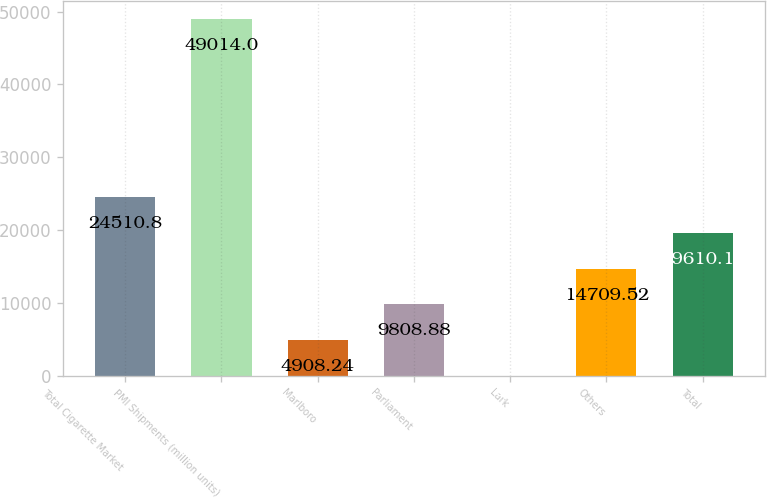<chart> <loc_0><loc_0><loc_500><loc_500><bar_chart><fcel>Total Cigarette Market<fcel>PMI Shipments (million units)<fcel>Marlboro<fcel>Parliament<fcel>Lark<fcel>Others<fcel>Total<nl><fcel>24510.8<fcel>49014<fcel>4908.24<fcel>9808.88<fcel>7.6<fcel>14709.5<fcel>19610.2<nl></chart> 